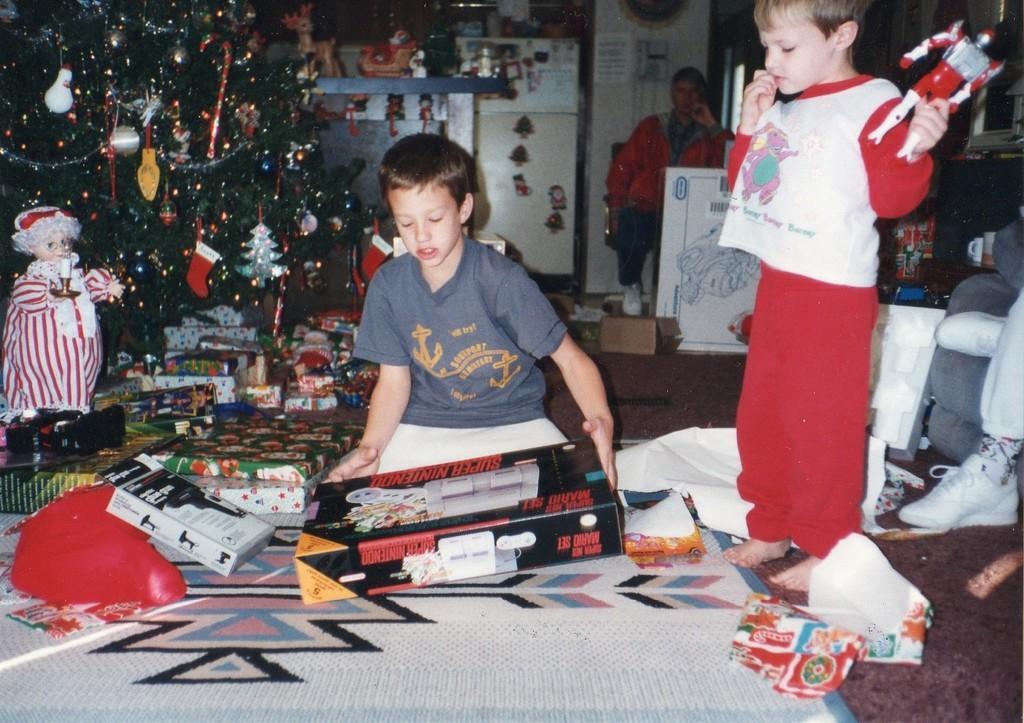In one or two sentences, can you explain what this image depicts? In this image there is a kid Unboxing a Christmas gift, beside him there is another kid standing by holding a toy in his hand, behind him there is a person seated on a sofa, in the background of the image there are a few toys and there is a Christmas tree. 